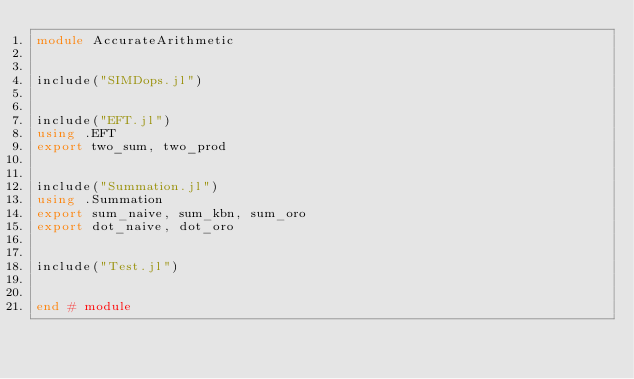<code> <loc_0><loc_0><loc_500><loc_500><_Julia_>module AccurateArithmetic


include("SIMDops.jl")


include("EFT.jl")
using .EFT
export two_sum, two_prod


include("Summation.jl")
using .Summation
export sum_naive, sum_kbn, sum_oro
export dot_naive, dot_oro


include("Test.jl")


end # module
</code> 